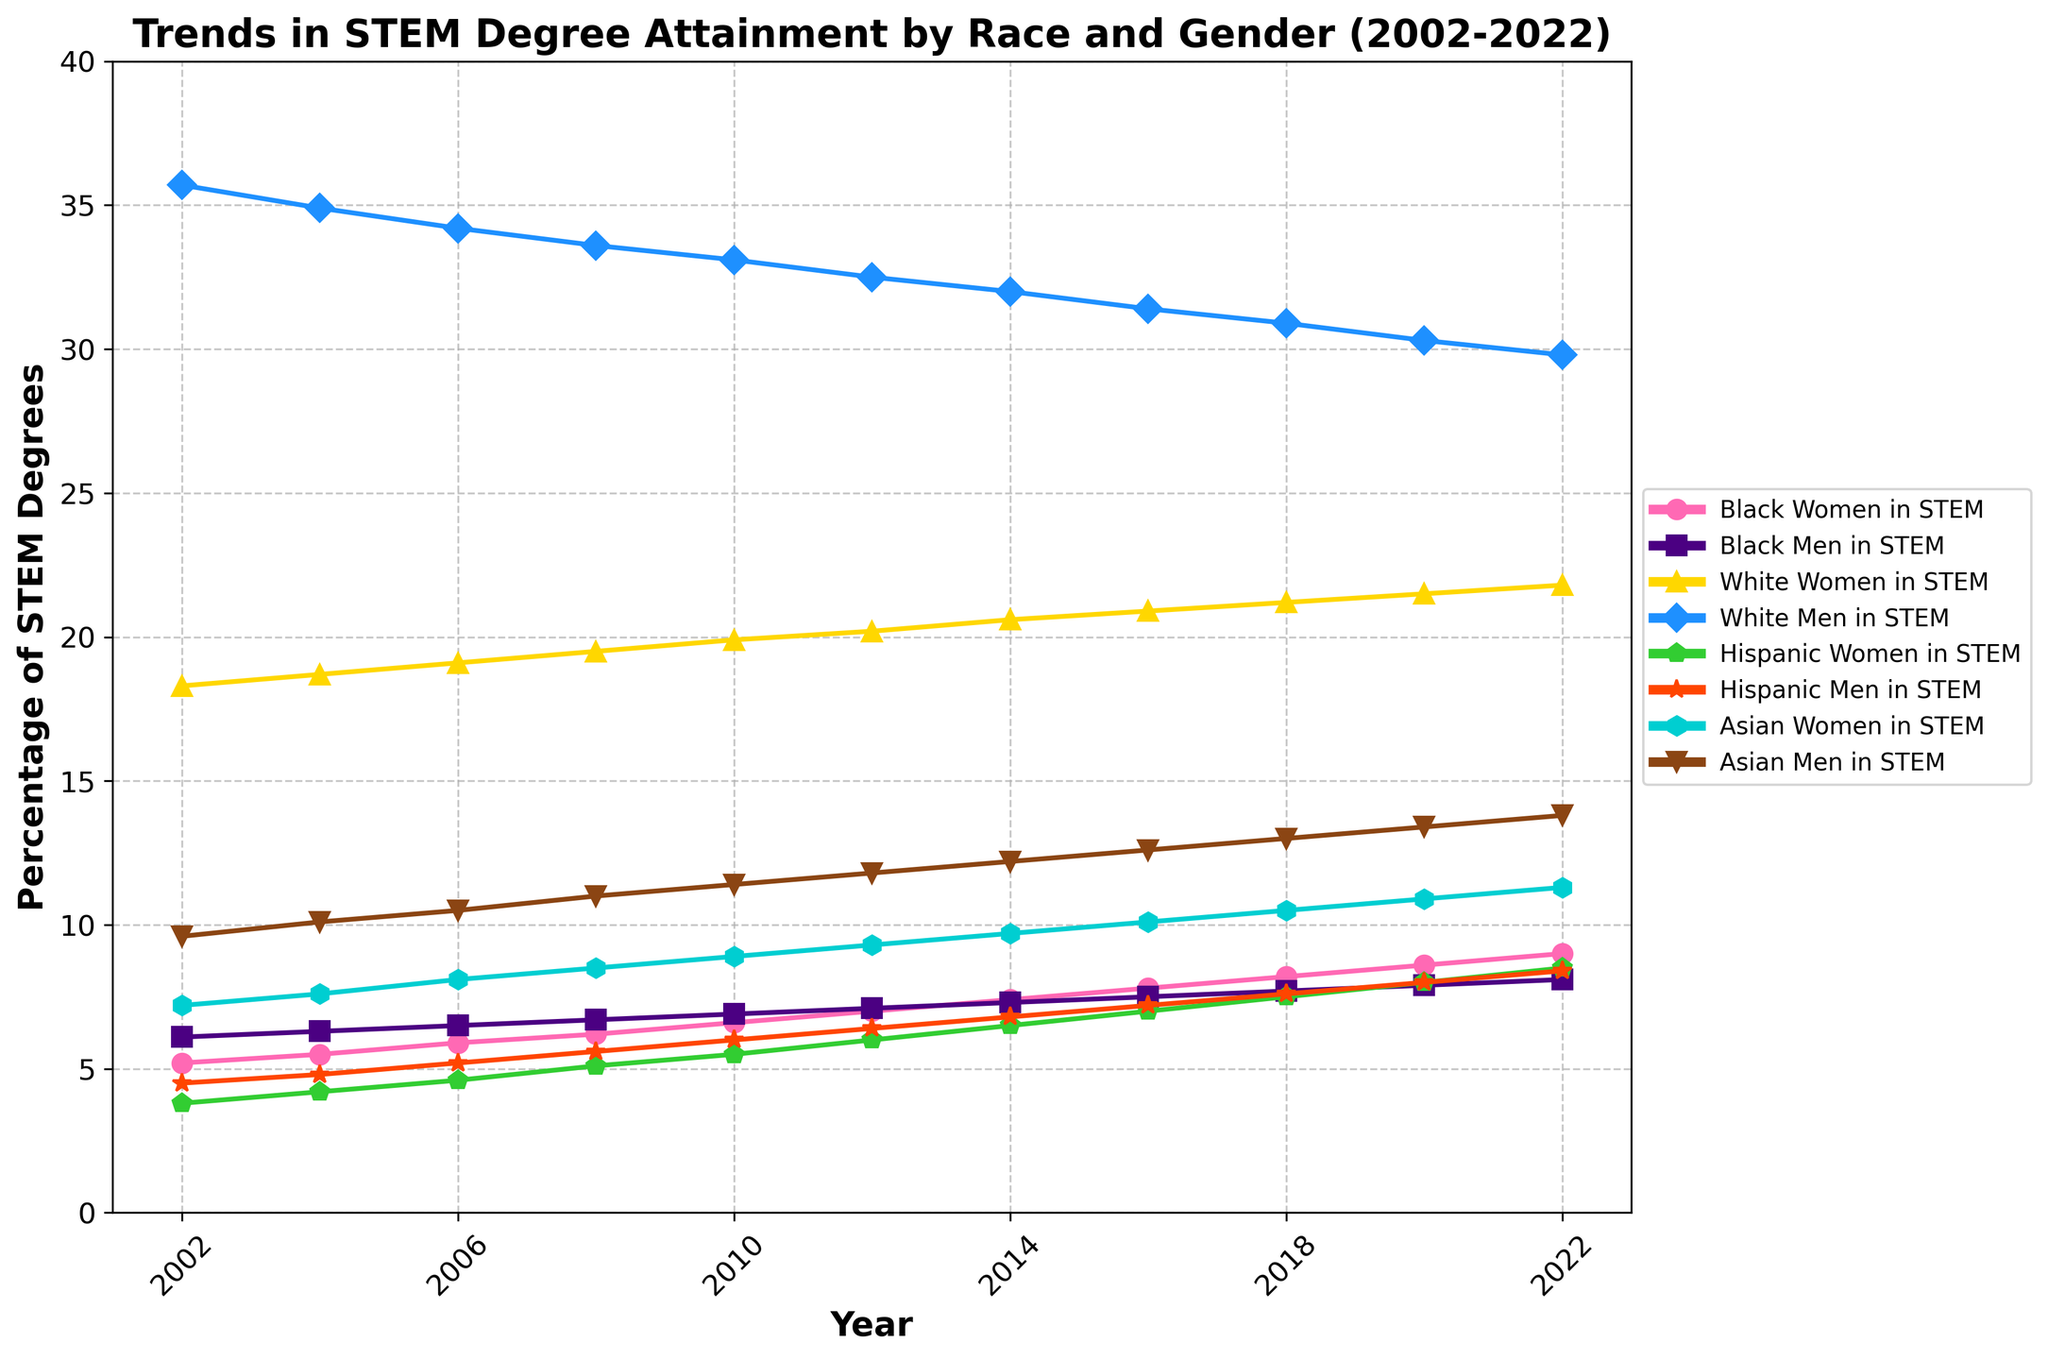What percentage of STEM degrees were obtained by Black Women in 2022? Locate the precise data point for Black Women in STEM for the year 2022 by finding the intersection of "Black Women in STEM" label and 2022 on the x-axis.
Answer: 9.0 How did the percentage of STEM degrees obtained by Hispanic Men change from 2002 to 2022? Subtract the percentage of Hispanic Men in 2002 from the percentage in 2022 to determine the change: 8.4 - 4.5 = 3.9.
Answer: 3.9 Which group had the highest percentage of STEM degrees in 2008? Compare all the values for the year 2008 and identify the highest one:  Black Men, Black Women, White Women, White Men, Hispanic Women, Hispanic Men, Asian Women, and Asian Men. White Men had the highest percentage.
Answer: White Men What is the difference in the percentage of STEM degrees obtained by Asian Women and Asian Men in 2014? Subtract the percentage of Asian Women from Asian Men for the year 2014: 12.2 - 9.7 = 2.5.
Answer: 2.5 Which racial or gender group consistently showed an increasing trend over the entire period? Check the trends for all the groups from 2002 to 2022 and see which ones have only increased. Both Hispanic Women and Black Women show consistent increases.
Answer: Hispanic Women and Black Women Between Black Men and White Men, who experienced a greater change in percentage points from 2002 to 2022? Calculate the change for both groups: Black Men (8.1 - 6.1 = 2.0), White Men (29.8 - 35.7 = -5.9). Compare the magnitudes.
Answer: White Men How does the percentage of Hispanic Women in 2010 compare to that of Black Women in the same year? Look at both data points in 2010 and compare them: Hispanic Women (5.5), Black Women (6.6). Hispanic Women have a smaller percentage.
Answer: Black Women What is the average percentage of STEM degrees obtained by Asian Men from 2002 to 2022? Add all the percentages for Asian Men and divide by the number of years: (9.6 + 10.1 + 10.5 + 11.0 + 11.4 + 11.8 + 12.2 + 12.6 + 13.0 + 13.4 + 13.8) / 11 = 11.7.
Answer: 11.7 What is the overall trend for White Women in STEM degrees over the 20-year period? Observe the changes in the percentage for White Women from 2002 to 2022. It gradually increases.
Answer: Increasing Who had a higher percentage increase, Asian Women or Hispanic Men, from 2002 to 2022? Calculate the percentage increase for both groups: Asian Women (11.3 - 7.2 = 4.1), Hispanic Men (8.4 - 4.5 = 3.9). Asian Women had a higher increase.
Answer: Asian Women 